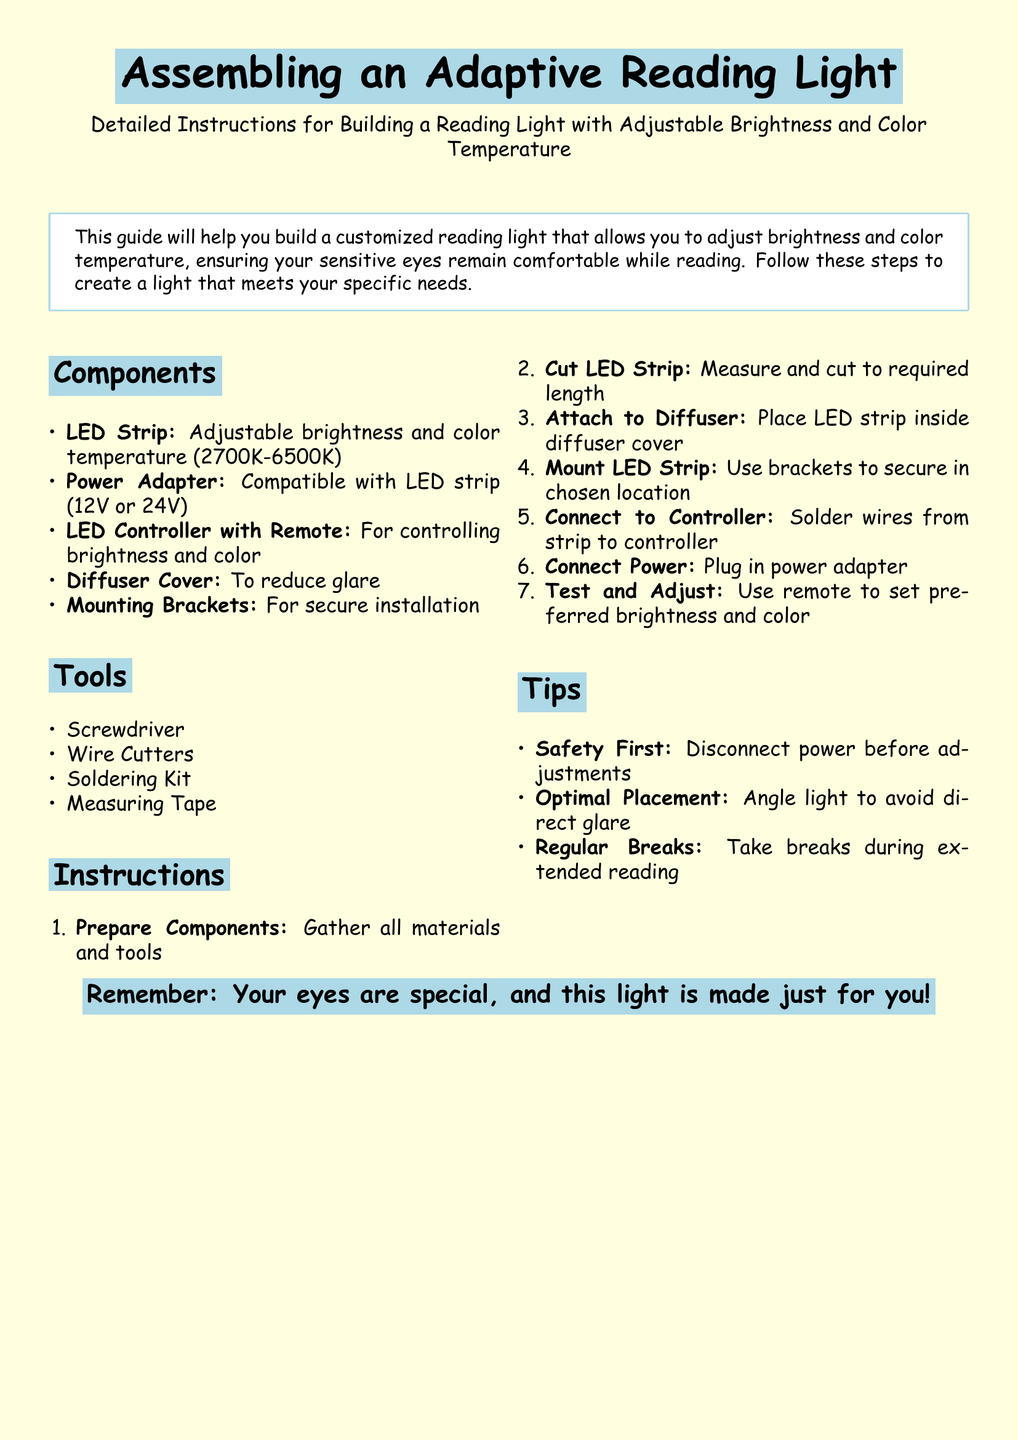what is the color temperature range of the LED strip? The LED strip has an adjustable color temperature ranging from 2700K to 6500K.
Answer: 2700K-6500K what tool is needed to cut wires? The document lists wire cutters as a necessary tool for the assembly.
Answer: Wire Cutters how many components are listed in the assembly instructions? There are five components listed under the "Components" section of the document.
Answer: Five what is the first step in the assembly instructions? The first step is to gather all materials and tools needed for assembly.
Answer: Prepare Components which item is used to reduce glare? The diffuser cover is specifically mentioned to reduce glare when using the reading light.
Answer: Diffuser Cover what is the purpose of the LED controller? The LED controller is used for controlling the brightness and color of the light.
Answer: Controlling brightness and color how should the light be positioned for optimal use? The instructions suggest angling the light to avoid direct glare when reading.
Answer: Angle light to avoid glare what should you do before making adjustments? It is advised to disconnect power before making any adjustments to ensure safety.
Answer: Disconnect power 